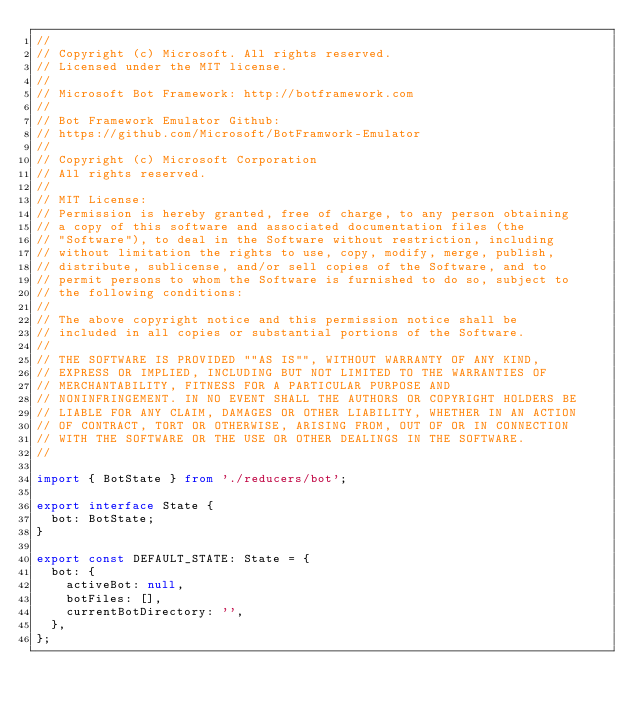Convert code to text. <code><loc_0><loc_0><loc_500><loc_500><_TypeScript_>//
// Copyright (c) Microsoft. All rights reserved.
// Licensed under the MIT license.
//
// Microsoft Bot Framework: http://botframework.com
//
// Bot Framework Emulator Github:
// https://github.com/Microsoft/BotFramwork-Emulator
//
// Copyright (c) Microsoft Corporation
// All rights reserved.
//
// MIT License:
// Permission is hereby granted, free of charge, to any person obtaining
// a copy of this software and associated documentation files (the
// "Software"), to deal in the Software without restriction, including
// without limitation the rights to use, copy, modify, merge, publish,
// distribute, sublicense, and/or sell copies of the Software, and to
// permit persons to whom the Software is furnished to do so, subject to
// the following conditions:
//
// The above copyright notice and this permission notice shall be
// included in all copies or substantial portions of the Software.
//
// THE SOFTWARE IS PROVIDED ""AS IS"", WITHOUT WARRANTY OF ANY KIND,
// EXPRESS OR IMPLIED, INCLUDING BUT NOT LIMITED TO THE WARRANTIES OF
// MERCHANTABILITY, FITNESS FOR A PARTICULAR PURPOSE AND
// NONINFRINGEMENT. IN NO EVENT SHALL THE AUTHORS OR COPYRIGHT HOLDERS BE
// LIABLE FOR ANY CLAIM, DAMAGES OR OTHER LIABILITY, WHETHER IN AN ACTION
// OF CONTRACT, TORT OR OTHERWISE, ARISING FROM, OUT OF OR IN CONNECTION
// WITH THE SOFTWARE OR THE USE OR OTHER DEALINGS IN THE SOFTWARE.
//

import { BotState } from './reducers/bot';

export interface State {
  bot: BotState;
}

export const DEFAULT_STATE: State = {
  bot: {
    activeBot: null,
    botFiles: [],
    currentBotDirectory: '',
  },
};
</code> 